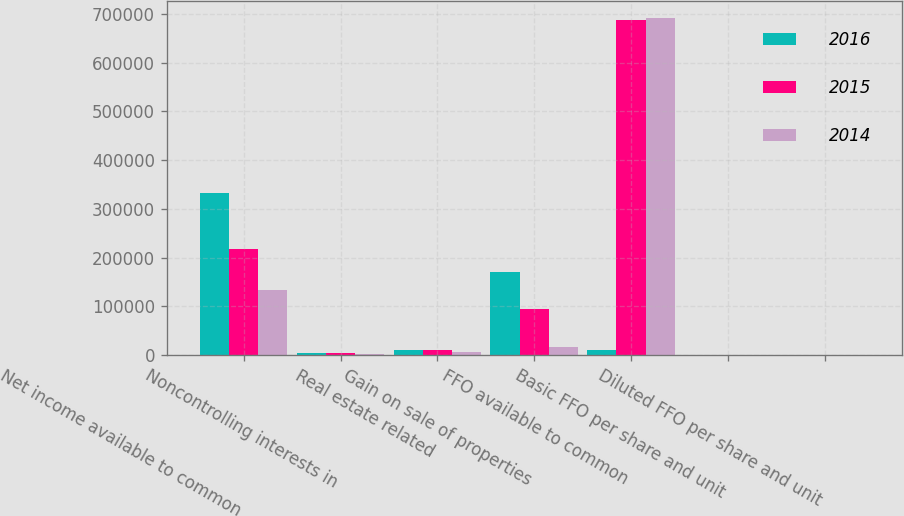Convert chart. <chart><loc_0><loc_0><loc_500><loc_500><stacked_bar_chart><ecel><fcel>Net income available to common<fcel>Noncontrolling interests in<fcel>Real estate related<fcel>Gain on sale of properties<fcel>FFO available to common<fcel>Basic FFO per share and unit<fcel>Diluted FFO per share and unit<nl><fcel>2016<fcel>332088<fcel>5298<fcel>11246<fcel>169902<fcel>11418<fcel>5.69<fcel>5.67<nl><fcel>2015<fcel>217266<fcel>4442<fcel>11418<fcel>94604<fcel>687896<fcel>4.88<fcel>4.86<nl><fcel>2014<fcel>132718<fcel>2767<fcel>7537<fcel>15945<fcel>691966<fcel>5.08<fcel>5.04<nl></chart> 